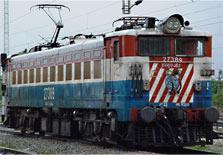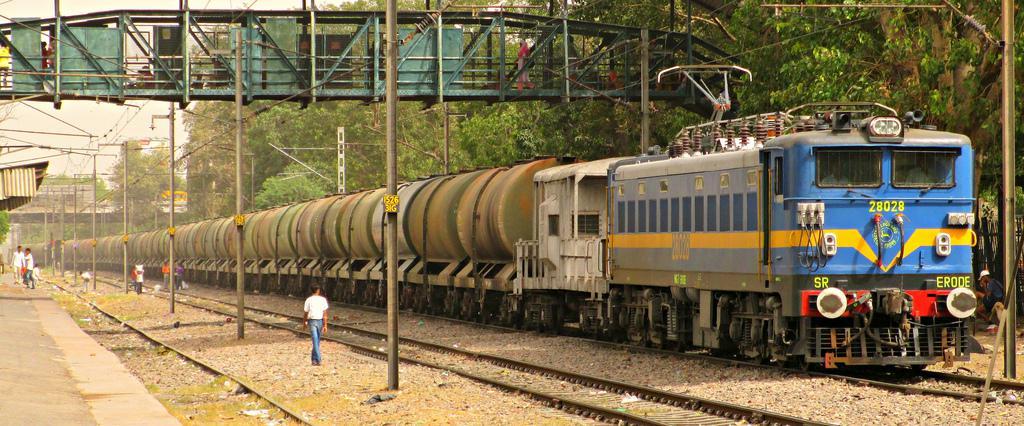The first image is the image on the left, the second image is the image on the right. Examine the images to the left and right. Is the description "Each of the images shows a train pointed in the same direction." accurate? Answer yes or no. Yes. The first image is the image on the left, the second image is the image on the right. Considering the images on both sides, is "An image shows a train with stripes of blue on the bottom, followed by red, white, red, and white on top." valid? Answer yes or no. No. 